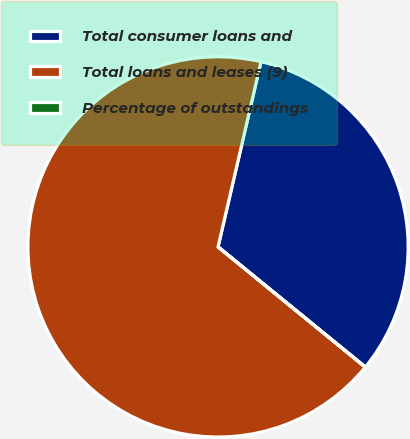Convert chart. <chart><loc_0><loc_0><loc_500><loc_500><pie_chart><fcel>Total consumer loans and<fcel>Total loans and leases (9)<fcel>Percentage of outstandings<nl><fcel>32.26%<fcel>67.73%<fcel>0.01%<nl></chart> 